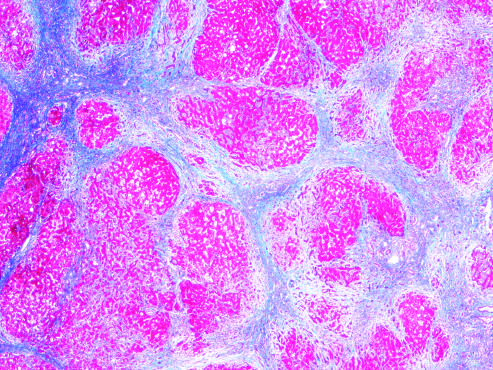when are most scars gone masson trichrome stain?
Answer the question using a single word or phrase. After abstinence 